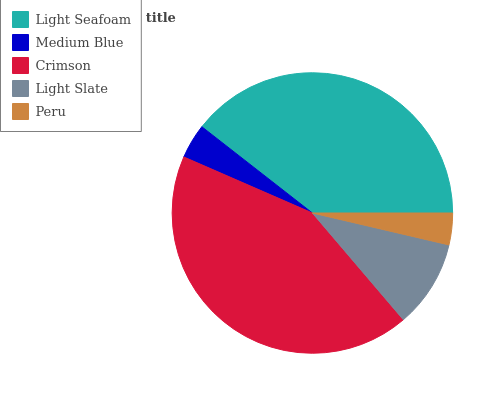Is Peru the minimum?
Answer yes or no. Yes. Is Crimson the maximum?
Answer yes or no. Yes. Is Medium Blue the minimum?
Answer yes or no. No. Is Medium Blue the maximum?
Answer yes or no. No. Is Light Seafoam greater than Medium Blue?
Answer yes or no. Yes. Is Medium Blue less than Light Seafoam?
Answer yes or no. Yes. Is Medium Blue greater than Light Seafoam?
Answer yes or no. No. Is Light Seafoam less than Medium Blue?
Answer yes or no. No. Is Light Slate the high median?
Answer yes or no. Yes. Is Light Slate the low median?
Answer yes or no. Yes. Is Peru the high median?
Answer yes or no. No. Is Crimson the low median?
Answer yes or no. No. 